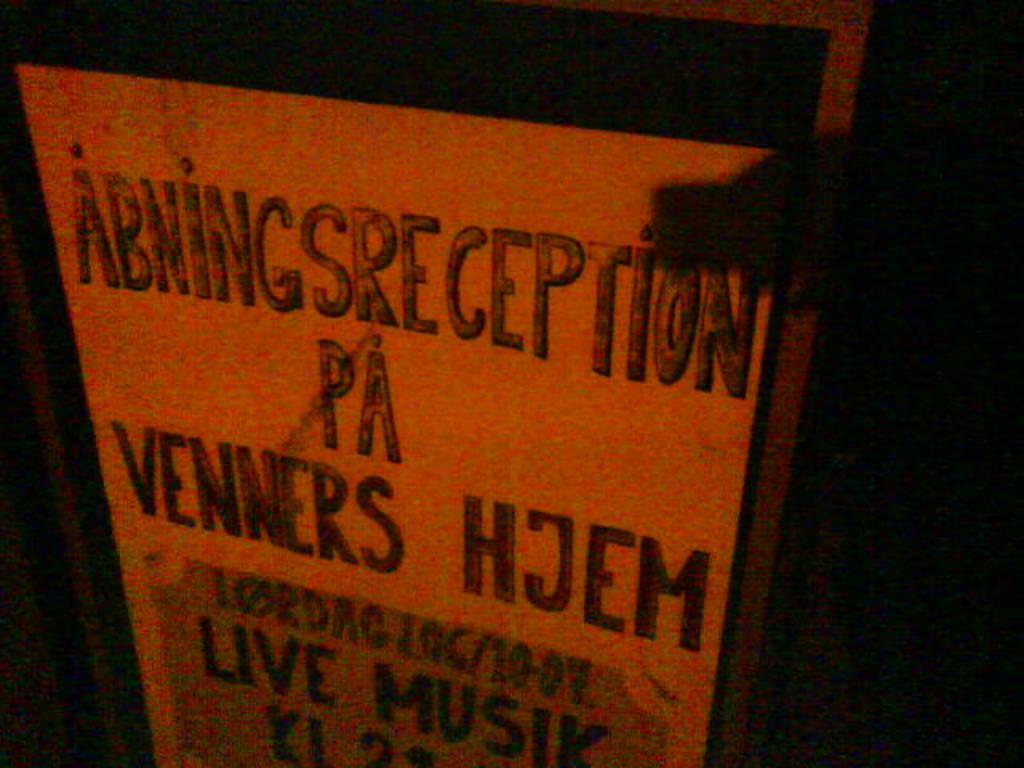What kind of musik?
Your answer should be very brief. Live. What is the first line?
Offer a very short reply. Abningsreception. 